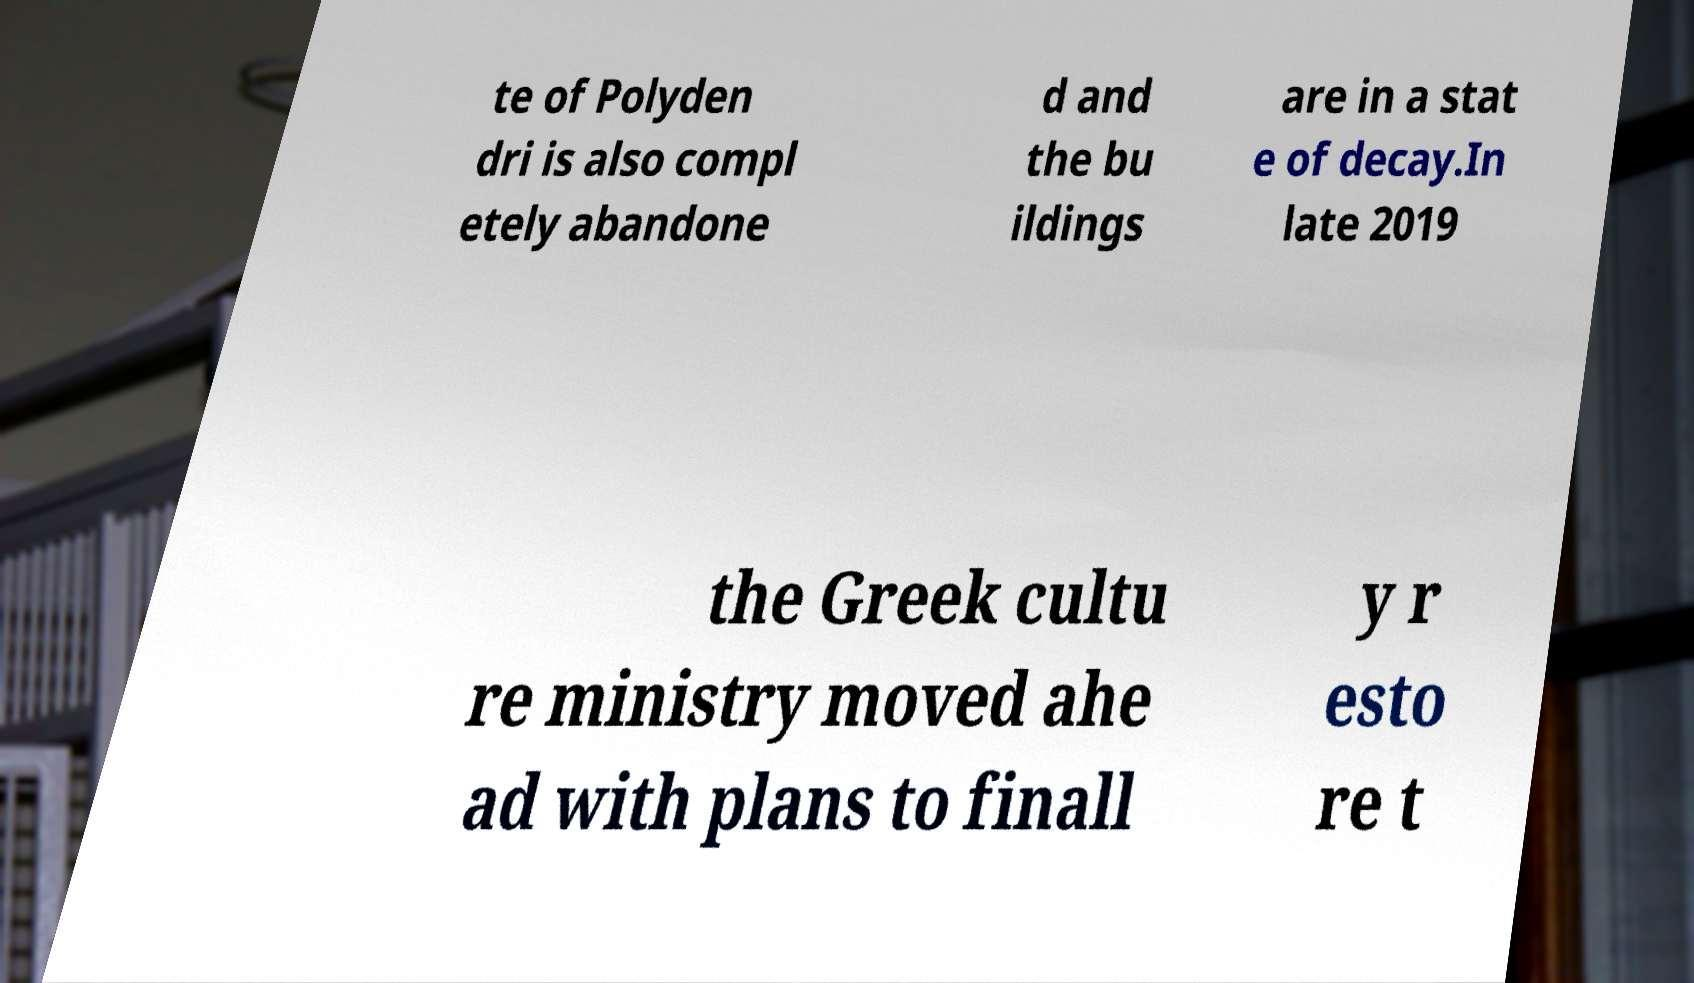Could you extract and type out the text from this image? te of Polyden dri is also compl etely abandone d and the bu ildings are in a stat e of decay.In late 2019 the Greek cultu re ministry moved ahe ad with plans to finall y r esto re t 